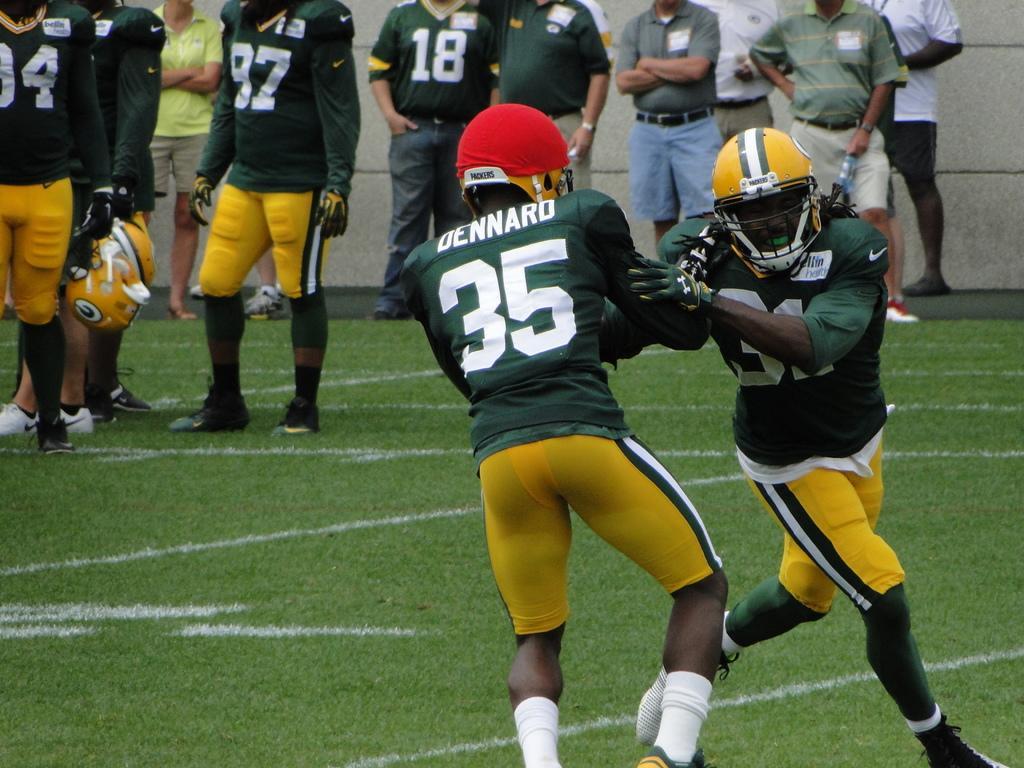How would you summarize this image in a sentence or two? In this image I can see group of people. In front I can see two persons and they are wearing green and yellow color dresses. In the background I can see the wall in gray color. 